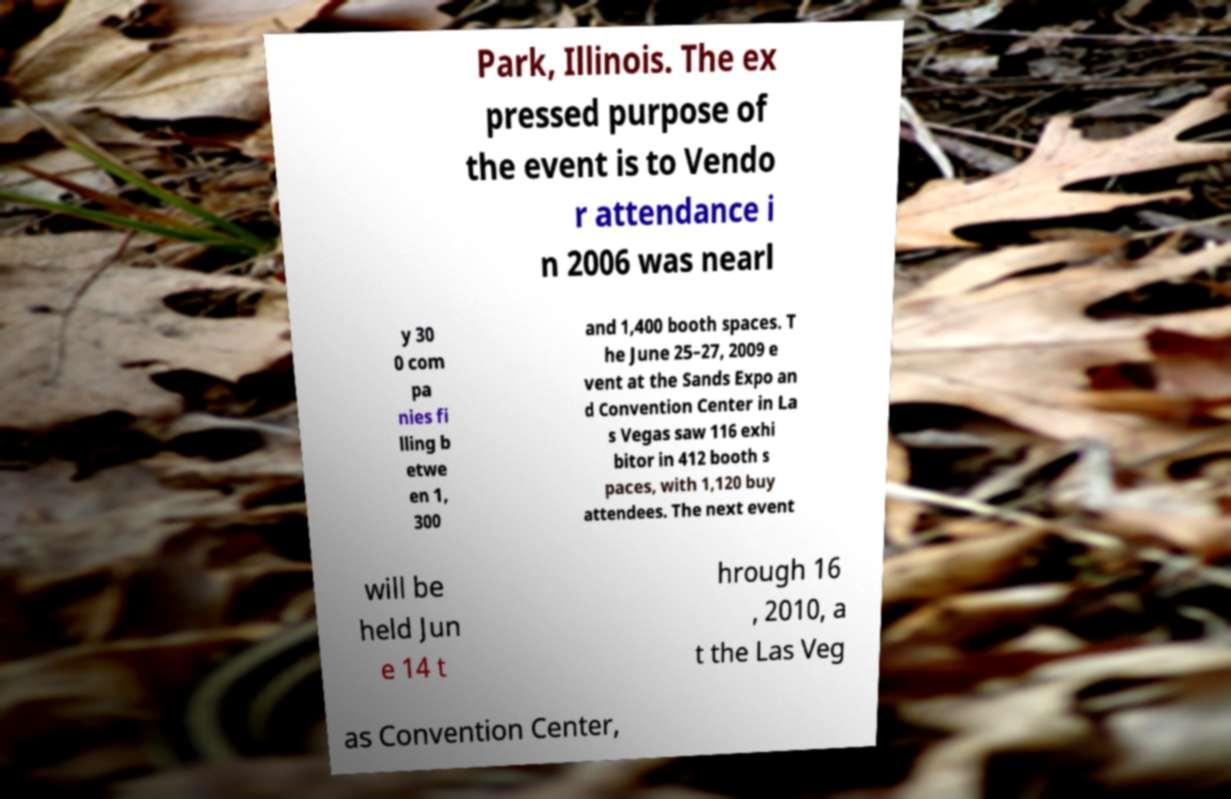What messages or text are displayed in this image? I need them in a readable, typed format. Park, Illinois. The ex pressed purpose of the event is to Vendo r attendance i n 2006 was nearl y 30 0 com pa nies fi lling b etwe en 1, 300 and 1,400 booth spaces. T he June 25–27, 2009 e vent at the Sands Expo an d Convention Center in La s Vegas saw 116 exhi bitor in 412 booth s paces, with 1,120 buy attendees. The next event will be held Jun e 14 t hrough 16 , 2010, a t the Las Veg as Convention Center, 